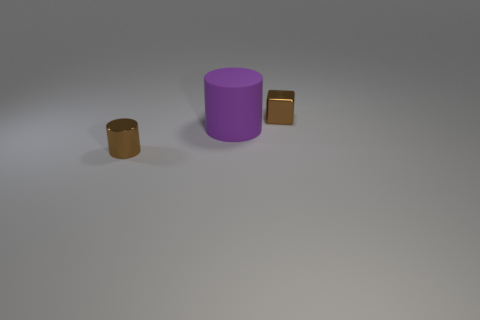There is a metal thing that is the same color as the metal block; what is its size?
Provide a succinct answer. Small. The metallic object that is the same size as the brown block is what color?
Offer a terse response. Brown. How many brown objects are the same shape as the purple thing?
Offer a very short reply. 1. How many cylinders are big purple things or brown objects?
Provide a short and direct response. 2. There is a small brown metallic object that is on the left side of the large purple thing; is it the same shape as the brown metallic thing that is behind the brown cylinder?
Make the answer very short. No. What is the tiny brown cylinder made of?
Your answer should be very brief. Metal. What is the shape of the metal thing that is the same color as the block?
Offer a terse response. Cylinder. What number of brown things have the same size as the purple rubber cylinder?
Ensure brevity in your answer.  0. How many things are either brown metal objects left of the big matte cylinder or objects that are behind the big cylinder?
Keep it short and to the point. 2. Is the small brown cylinder that is in front of the big purple cylinder made of the same material as the small brown thing that is behind the matte cylinder?
Offer a terse response. Yes. 